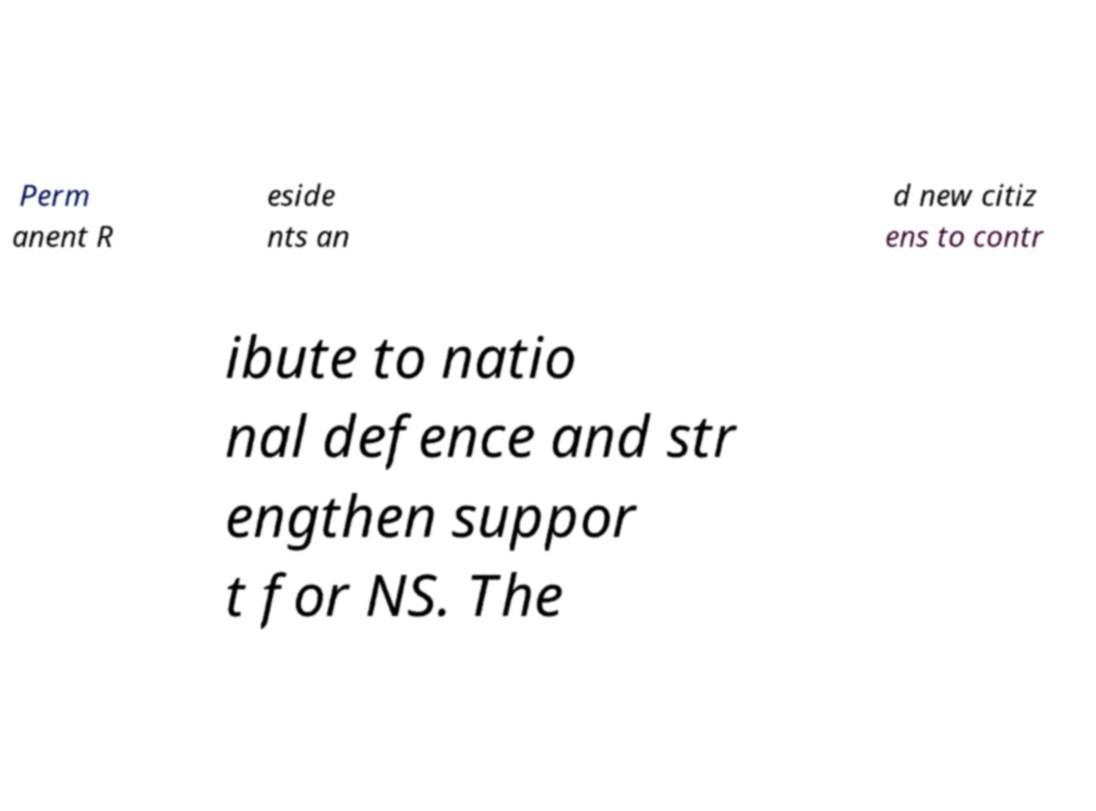Could you assist in decoding the text presented in this image and type it out clearly? Perm anent R eside nts an d new citiz ens to contr ibute to natio nal defence and str engthen suppor t for NS. The 